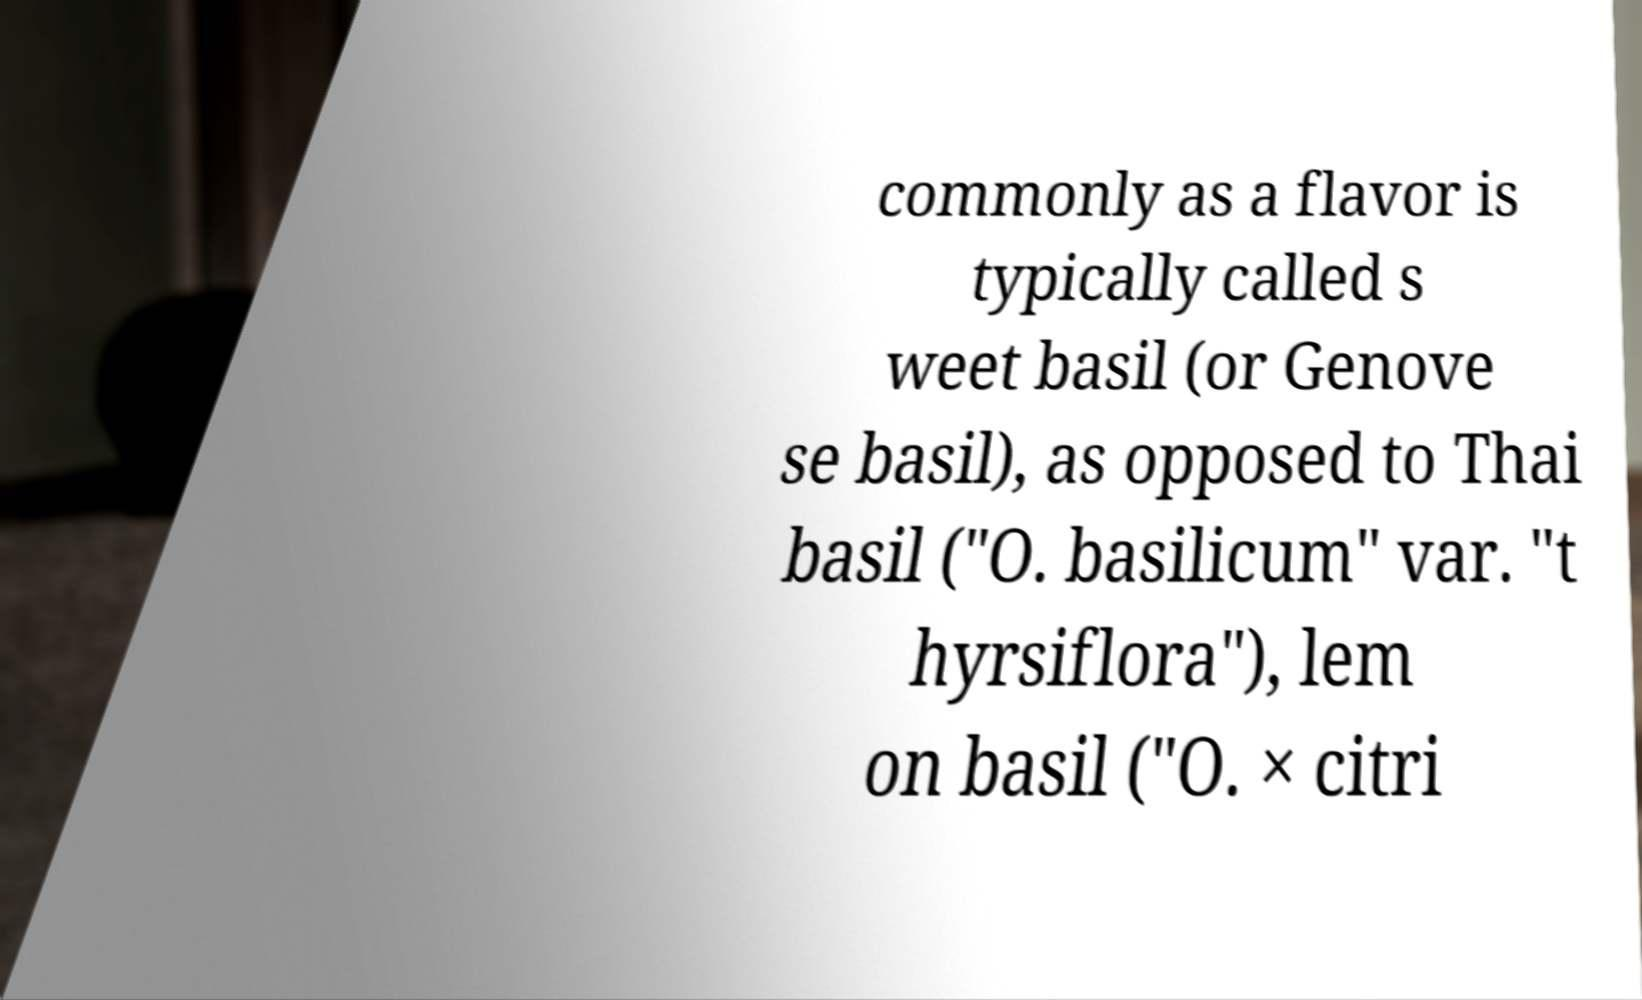I need the written content from this picture converted into text. Can you do that? commonly as a flavor is typically called s weet basil (or Genove se basil), as opposed to Thai basil ("O. basilicum" var. "t hyrsiflora"), lem on basil ("O. × citri 